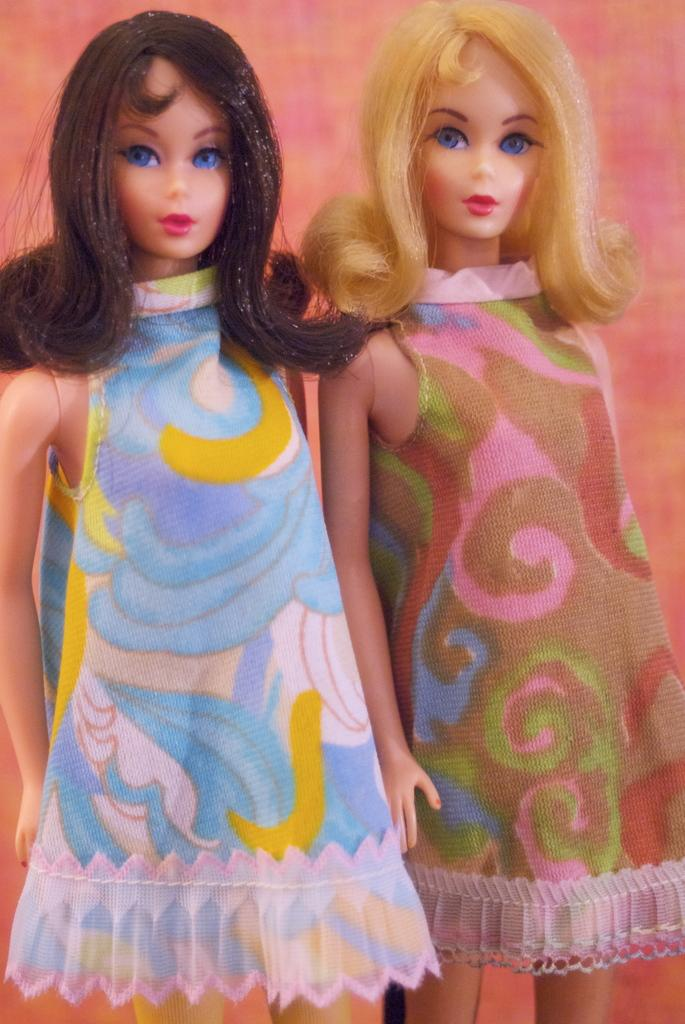How many dolls are present in the image? There are two dolls in the image. What type of grain is being used to create the texture of the dolls' clothing in the image? There is no reference to grain or any textures related to clothing in the image, as it features two dolls without any specific details about their clothing. 